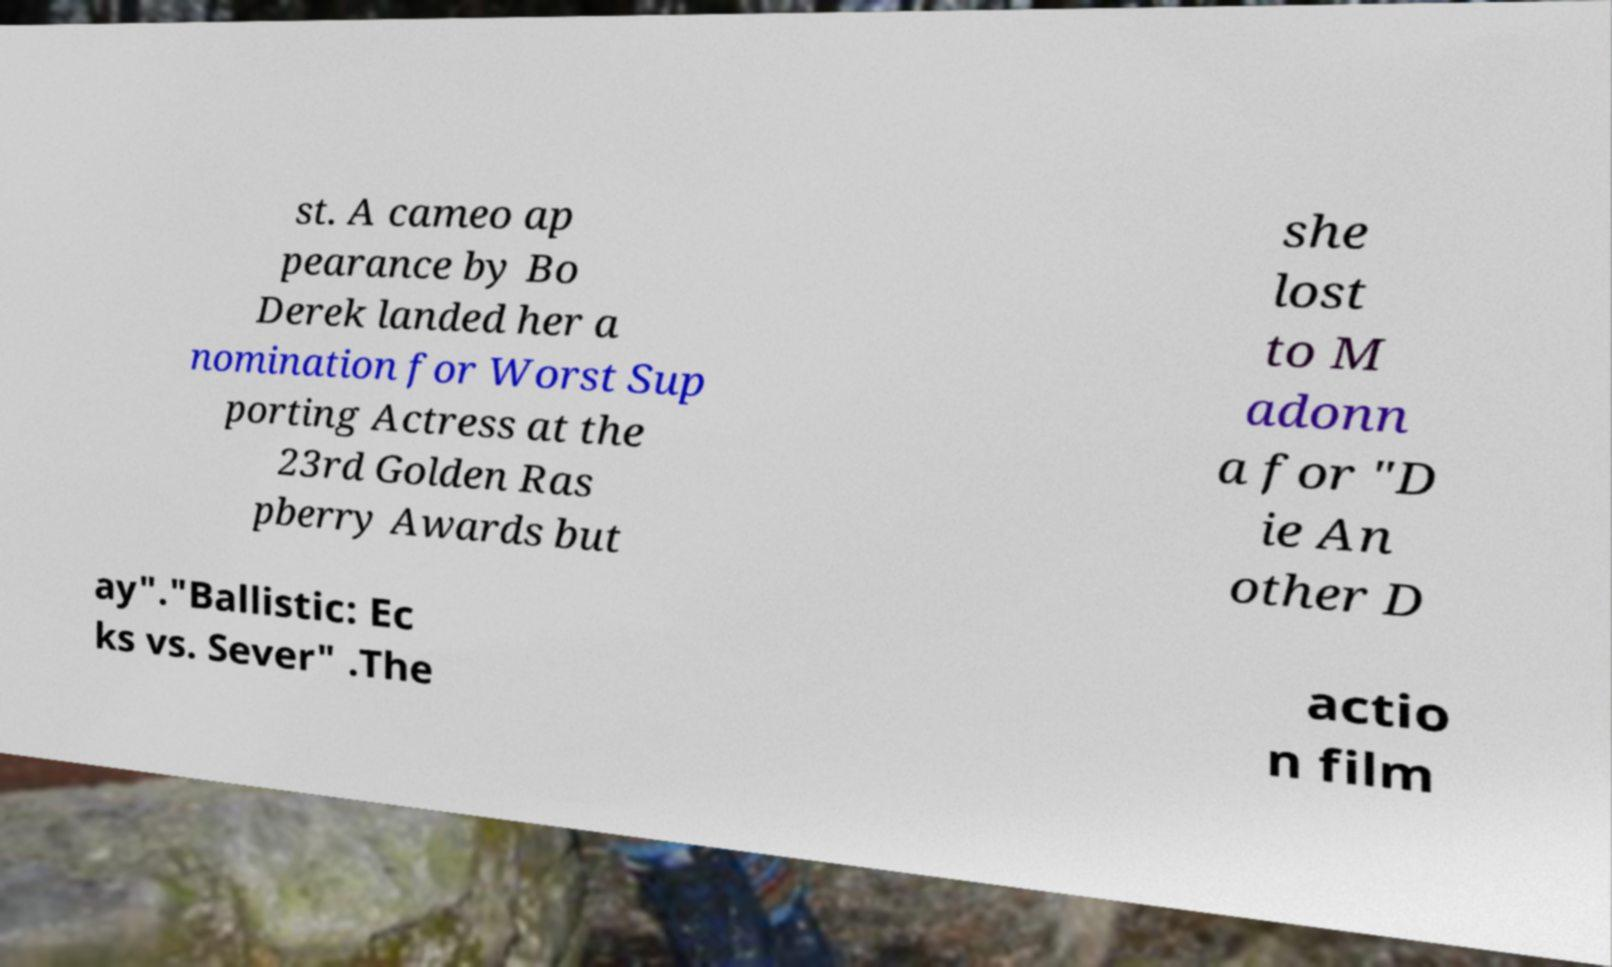Please identify and transcribe the text found in this image. st. A cameo ap pearance by Bo Derek landed her a nomination for Worst Sup porting Actress at the 23rd Golden Ras pberry Awards but she lost to M adonn a for "D ie An other D ay"."Ballistic: Ec ks vs. Sever" .The actio n film 